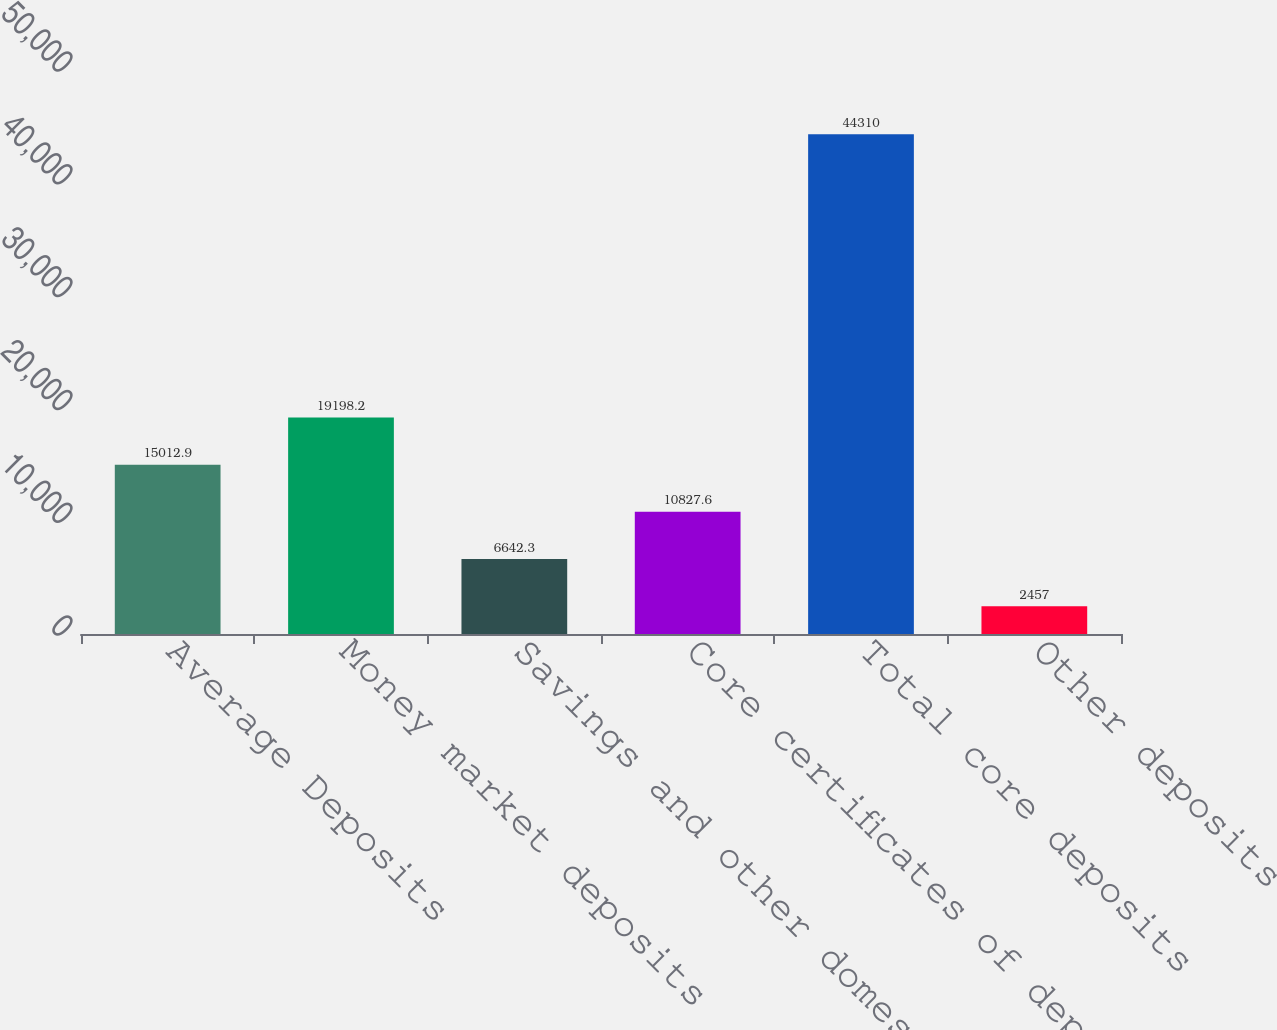Convert chart. <chart><loc_0><loc_0><loc_500><loc_500><bar_chart><fcel>Average Deposits<fcel>Money market deposits<fcel>Savings and other domestic<fcel>Core certificates of deposit<fcel>Total core deposits<fcel>Other deposits<nl><fcel>15012.9<fcel>19198.2<fcel>6642.3<fcel>10827.6<fcel>44310<fcel>2457<nl></chart> 